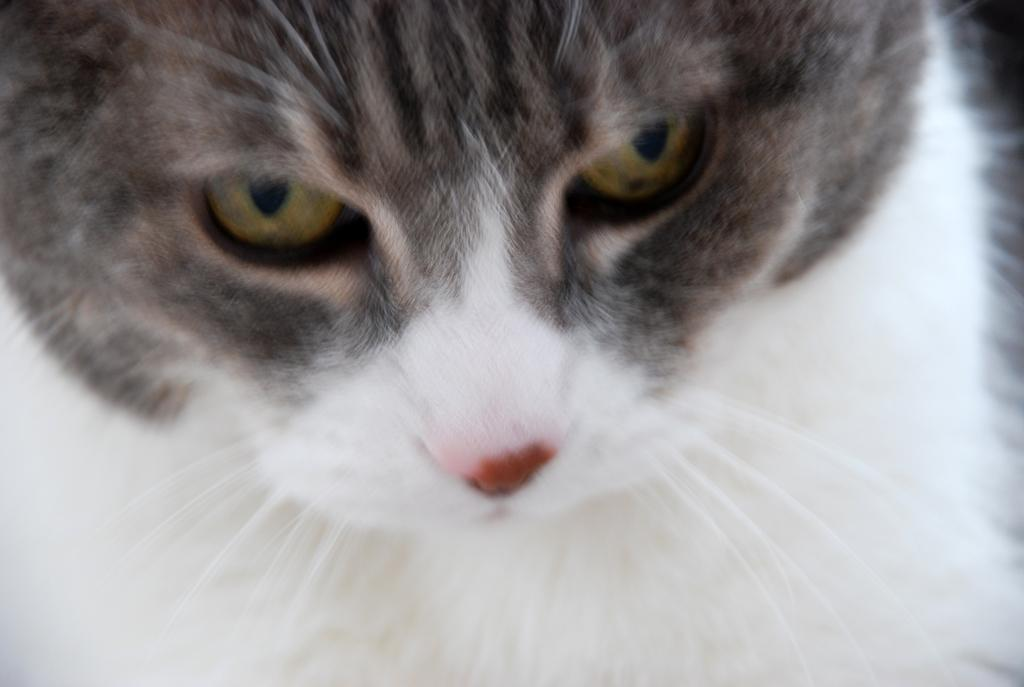What type of animal is in the image? There is a cat in the image. Can you describe the color of the cat? The cat is off white and grey in color. Based on the lighting in the image, when do you think it was taken? The image was likely taken during the day. What type of chair is the minister sitting on in the image? There is no minister or chair present in the image; it features a cat. 